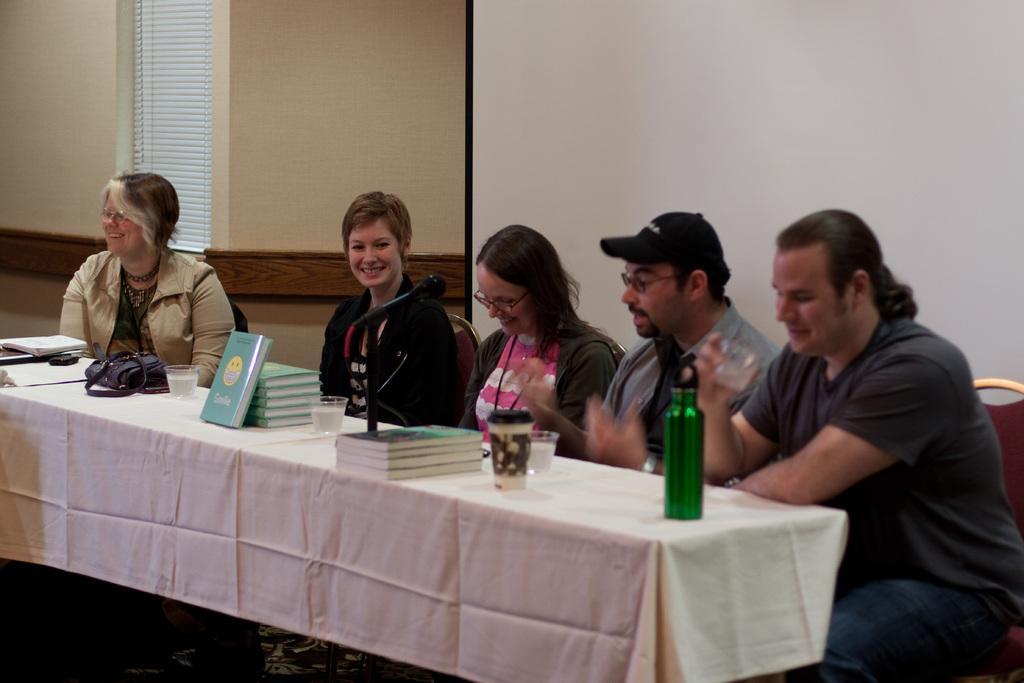Can you describe this image briefly? In this image I can see few people are sitting on the chairs around the table which is covered with a white cloth. On the table I can see few books, glasses, bottle, and one handbag. In the background there is a white color screen. 